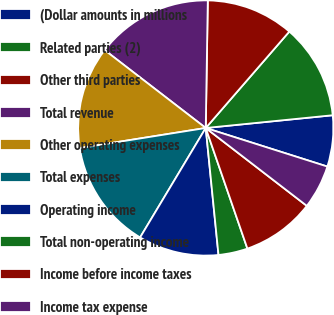<chart> <loc_0><loc_0><loc_500><loc_500><pie_chart><fcel>(Dollar amounts in millions<fcel>Related parties (2)<fcel>Other third parties<fcel>Total revenue<fcel>Other operating expenses<fcel>Total expenses<fcel>Operating income<fcel>Total non-operating income<fcel>Income before income taxes<fcel>Income tax expense<nl><fcel>6.48%<fcel>12.04%<fcel>11.11%<fcel>14.81%<fcel>12.96%<fcel>13.89%<fcel>10.19%<fcel>3.7%<fcel>9.26%<fcel>5.56%<nl></chart> 